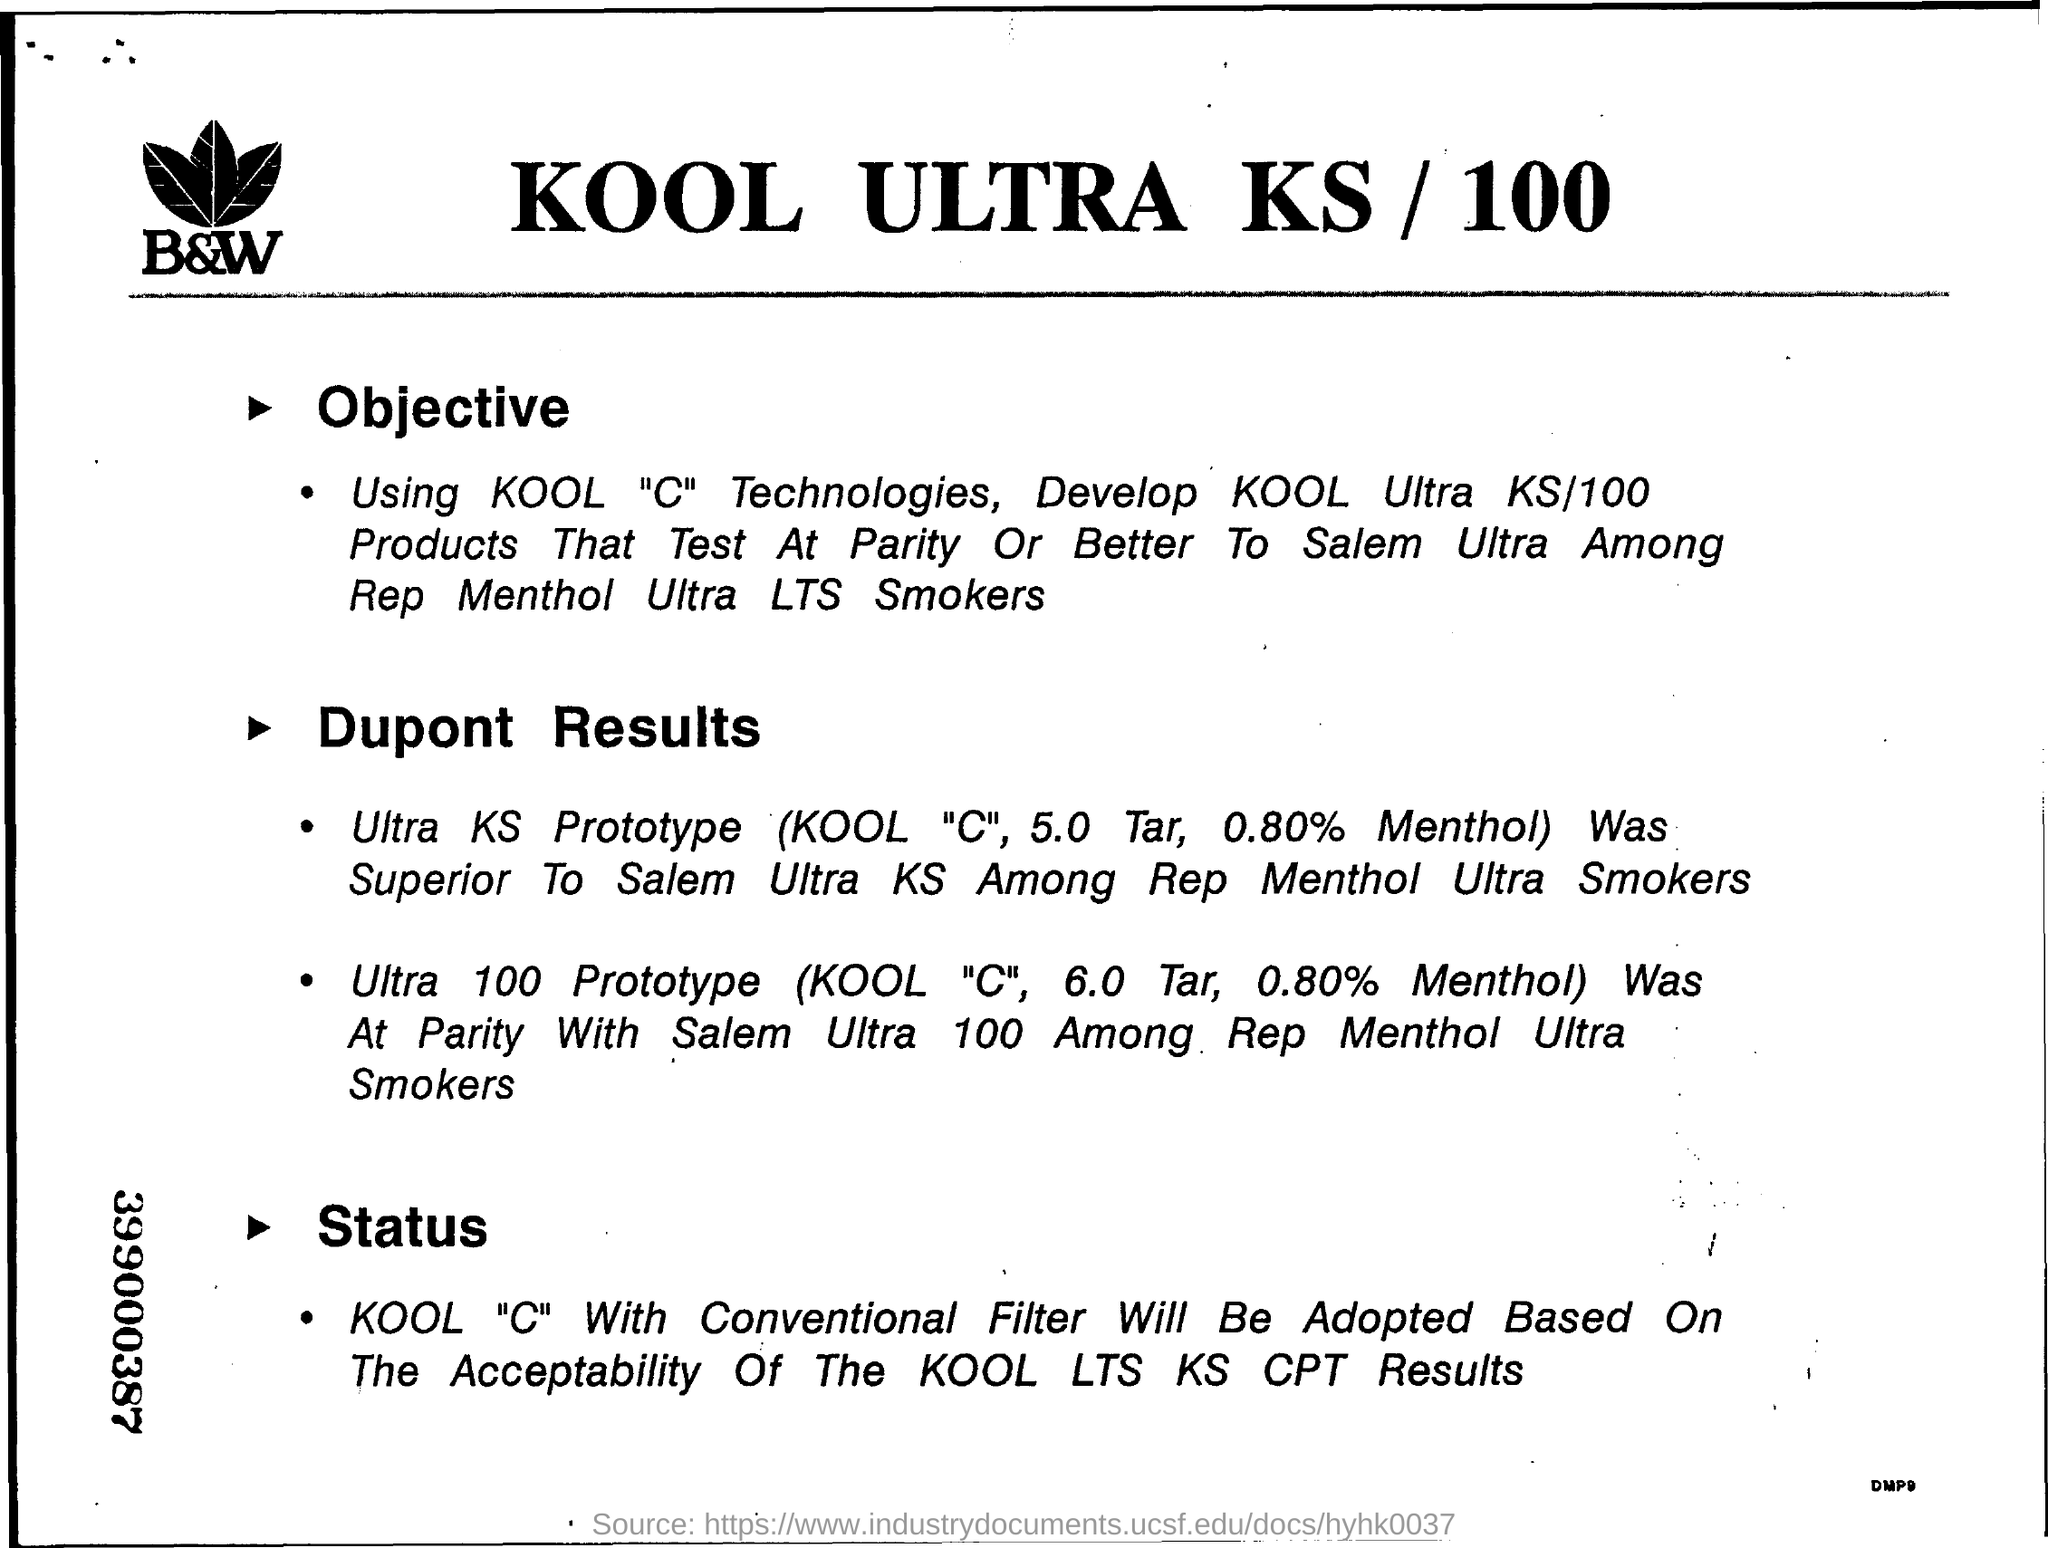What is the title of the document?
Provide a succinct answer. KOOL ULTRA KS / 100. Which is more superior out of Ultra KS Prototype  or Salem Ultra 100 among rep mentol ultra smokers?
Ensure brevity in your answer.  Ultra KS Prototype. KOOL "C" With Conventional Filter Will Be Adopted Based On The Acceptability Of The?
Keep it short and to the point. KOOL LTS KS CPT Results. What is the 9 digits number mentioned on the left margin?
Your answer should be very brief. 399000387. 